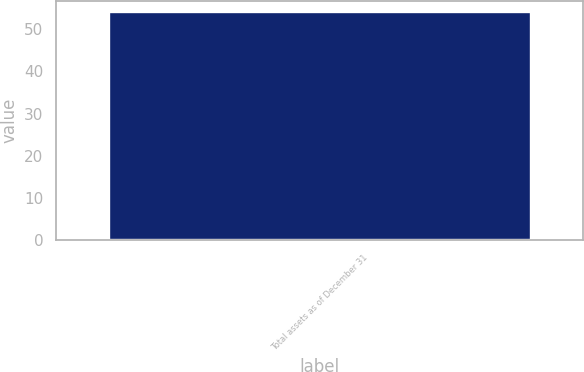Convert chart to OTSL. <chart><loc_0><loc_0><loc_500><loc_500><bar_chart><fcel>Total assets as of December 31<nl><fcel>54<nl></chart> 